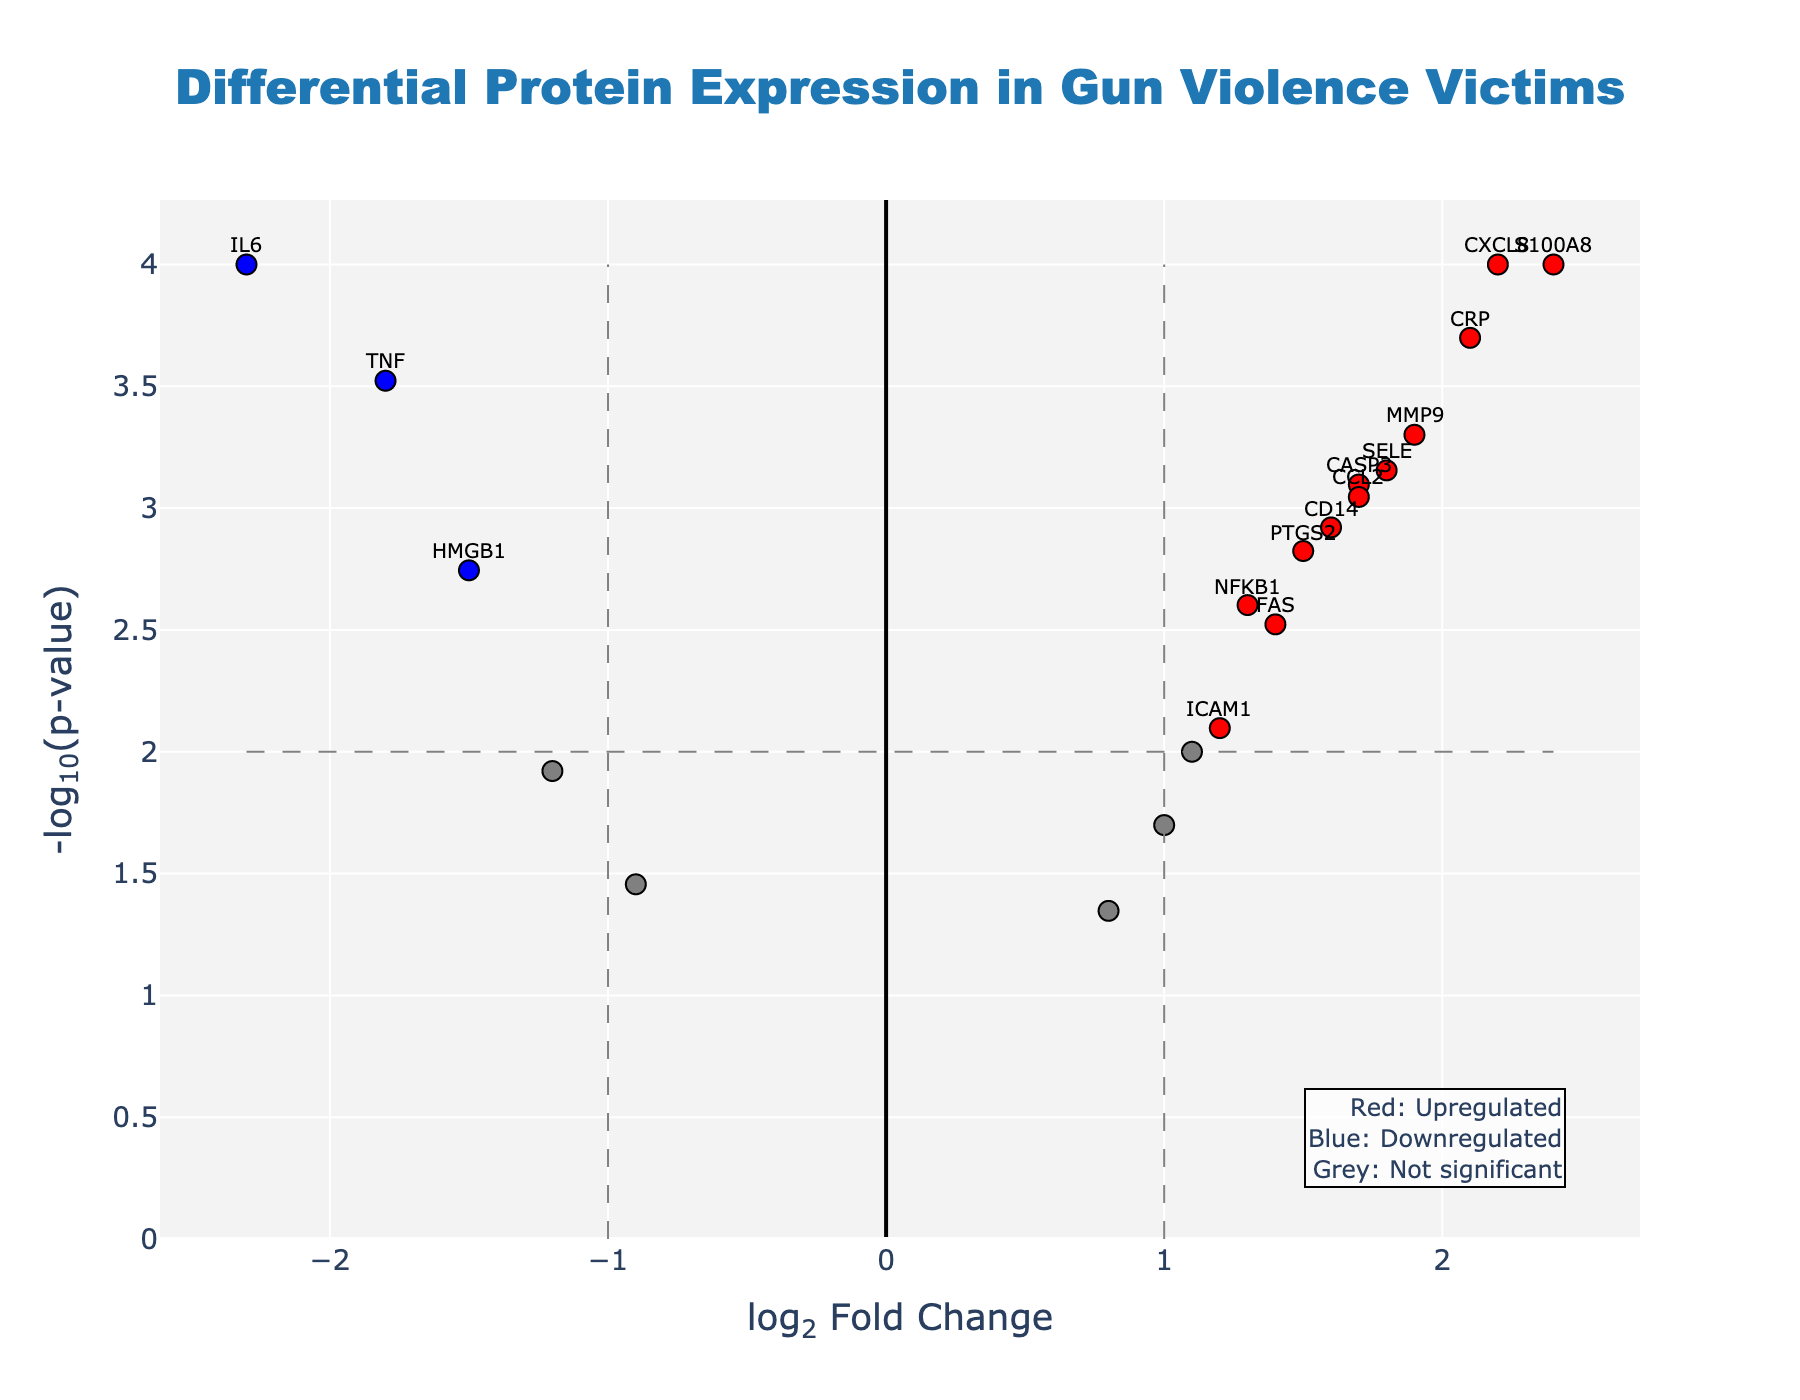What is the title of the plot? The title is found at the top of the plot and describes what the plot represents. In this case, it describes the plot as showing the differential protein expression in gun violence victims.
Answer: Differential Protein Expression in Gun Violence Victims What do the colors red, blue, and grey represent in the plot? The plot includes an annotation explaining the colors. Red indicates upregulated proteins, blue indicates downregulated proteins, and grey indicates proteins that are not significantly different.
Answer: Red: Upregulated, Blue: Downregulated, Grey: Not significant How many proteins are upregulated and significant in gun violence victims? Look for red points since they represent proteins that are both upregulated (log2FC > 1) and significant (-log10(p-value) > 2).
Answer: 8 Which protein has the highest log2 Fold Change (log2FC)? Identify the protein represented by the point furthest to the right on the x-axis. Based on the hover text or annotations, we can determine the gene.
Answer: S100A8 What threshold lines are present in the plot, and what do they signify? The plot has vertical and horizontal dashed lines. The vertical lines at log2FC = ±1 segregate upregulated and downregulated proteins. The horizontal line at -log10(p-value) = 2 helps identify significant proteins.
Answer: Vertical lines at log2FC = ±1, horizontal line at -log10(p-value) = 2 How many proteins exhibit a log2FC less than -1 and are significant? Look for blue-colored points with log2FC less than -1 and -log10(p-value) greater than 2. Count these points.
Answer: 3 Which significant protein has the lowest p-value? Look for the highest point along the y-axis, as -log10(p-value) is plotted on the y-axis. Check the hover text or annotation for this point.
Answer: IL6, CXCL8, S100A8 (all have p-value of 0.0001) What is the log2 Fold Change of the protein TNF, and is it significant? Find the TNF annotation or use the hover text if available. TNF's significance can be determined by its color and position relative to the thresholds lines.
Answer: -1.8, Yes Between the proteins CRP and PTGS2, which one is more upregulated in gun violence victims? Compare the log2FC values of CRP and PTGS2 and see which one has a higher value.
Answer: CRP (log2FC = 2.1) What differentiates upregulated and downregulated proteins in this plot? Upregulated proteins have log2FC values greater than 1, shown in red, and downregulated proteins have log2FC values less than -1, shown in blue. The thresholds are defined by the vertical dashed lines.
Answer: Log2FC > 1 for upregulated, Log2FC < -1 for downregulated 